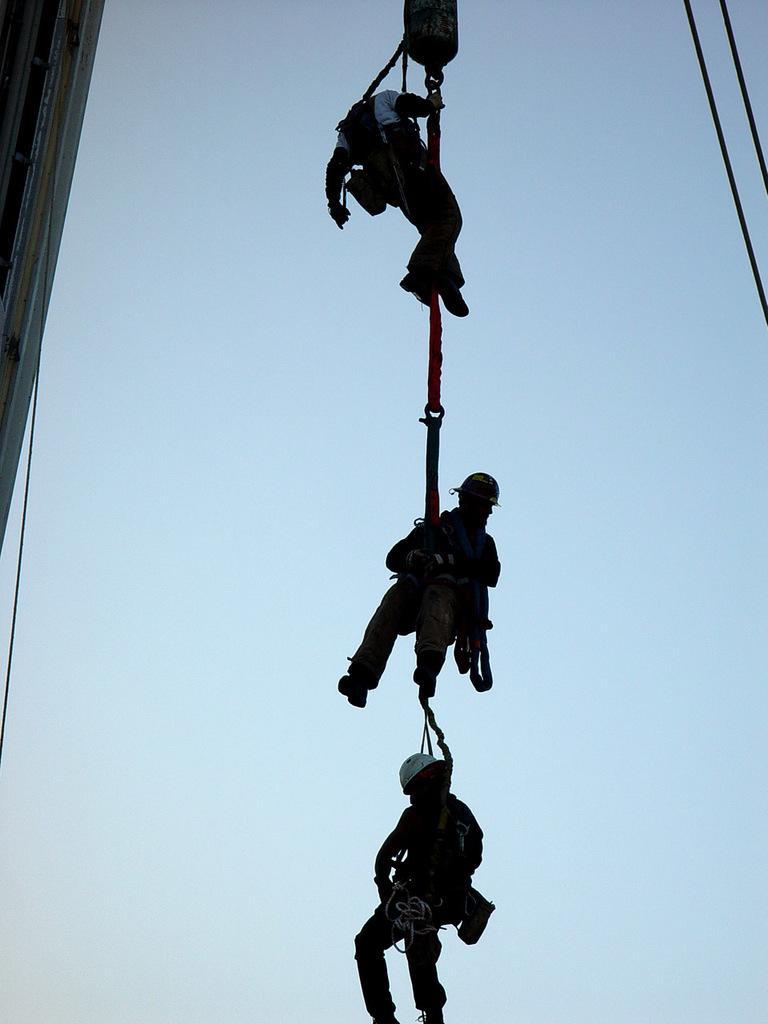Can you describe this image briefly? In this image in the center there are some persons who are in air, and on the right side there are some ropes and on the left side there is a building. In the background there is sky. 